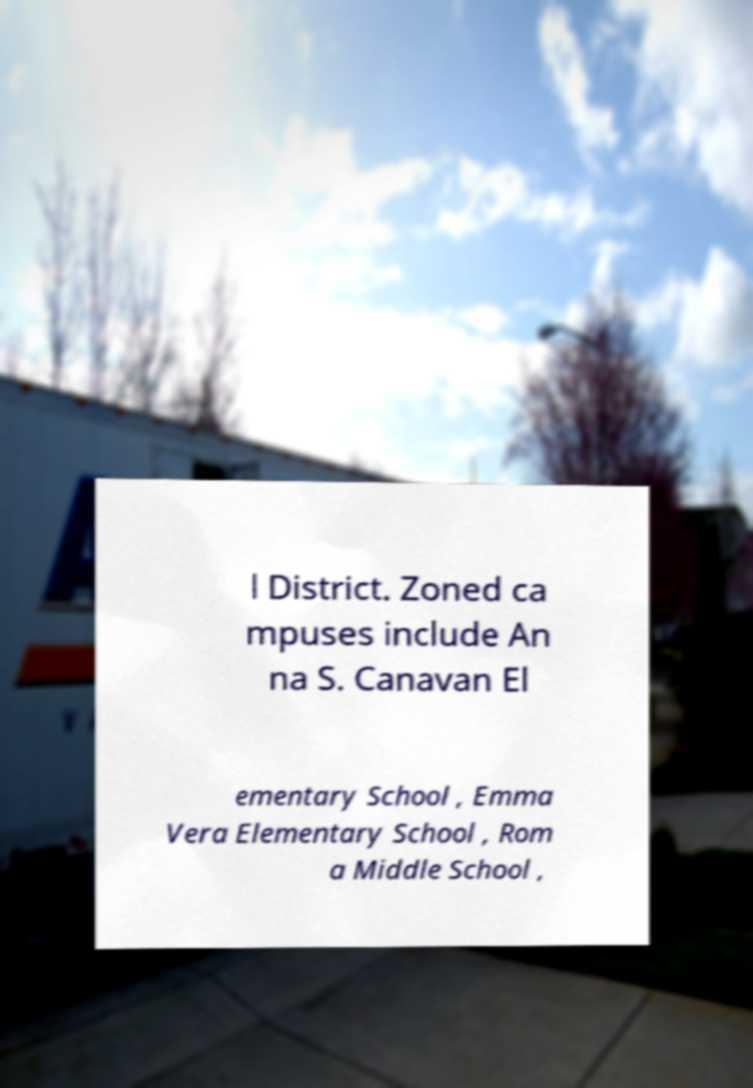Please read and relay the text visible in this image. What does it say? l District. Zoned ca mpuses include An na S. Canavan El ementary School , Emma Vera Elementary School , Rom a Middle School , 